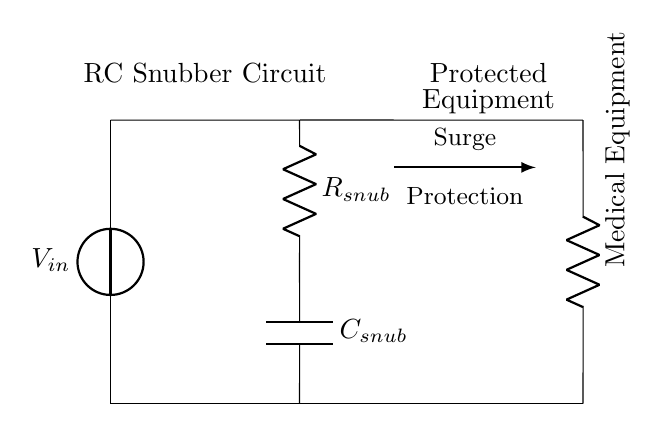What is the function of the resistor in this circuit? The resistor (R_snub) in an RC snubber circuit is primarily used to limit the current during surges, thereby protecting the connected medical equipment.
Answer: Limit current What type of circuit is represented here? This circuit is an RC snubber circuit, specifically designed for surge protection using a resistor and capacitor.
Answer: RC snubber circuit Which components are part of the snubber circuit? The snubber circuit consists of a resistor and a capacitor, labelled as R_snub and C_snub respectively.
Answer: Resistor and capacitor What is the role of the capacitor in this circuit? The capacitor (C_snub) stores electrical energy and helps absorb spikes in voltage during power surges, smoothing the voltage across the medical equipment.
Answer: Absorb voltage spikes How do the resistor and capacitor work together in this circuit? The resistor and capacitor form a low-pass filter, where the resistor limits the surge current and the capacitor absorbs excess voltage, thus protecting the load from transients.
Answer: Limit current and absorb voltage What does the arrow in the diagram indicate? The arrow indicates the flow of surge protection, showing that the RC snubber circuit is designed to protect the connected medical equipment from power surges.
Answer: Surge protection direction 